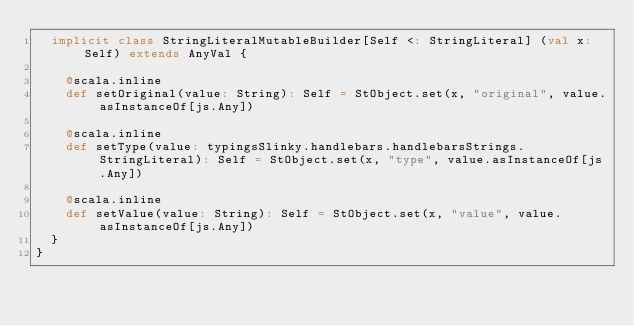Convert code to text. <code><loc_0><loc_0><loc_500><loc_500><_Scala_>  implicit class StringLiteralMutableBuilder[Self <: StringLiteral] (val x: Self) extends AnyVal {
    
    @scala.inline
    def setOriginal(value: String): Self = StObject.set(x, "original", value.asInstanceOf[js.Any])
    
    @scala.inline
    def setType(value: typingsSlinky.handlebars.handlebarsStrings.StringLiteral): Self = StObject.set(x, "type", value.asInstanceOf[js.Any])
    
    @scala.inline
    def setValue(value: String): Self = StObject.set(x, "value", value.asInstanceOf[js.Any])
  }
}
</code> 